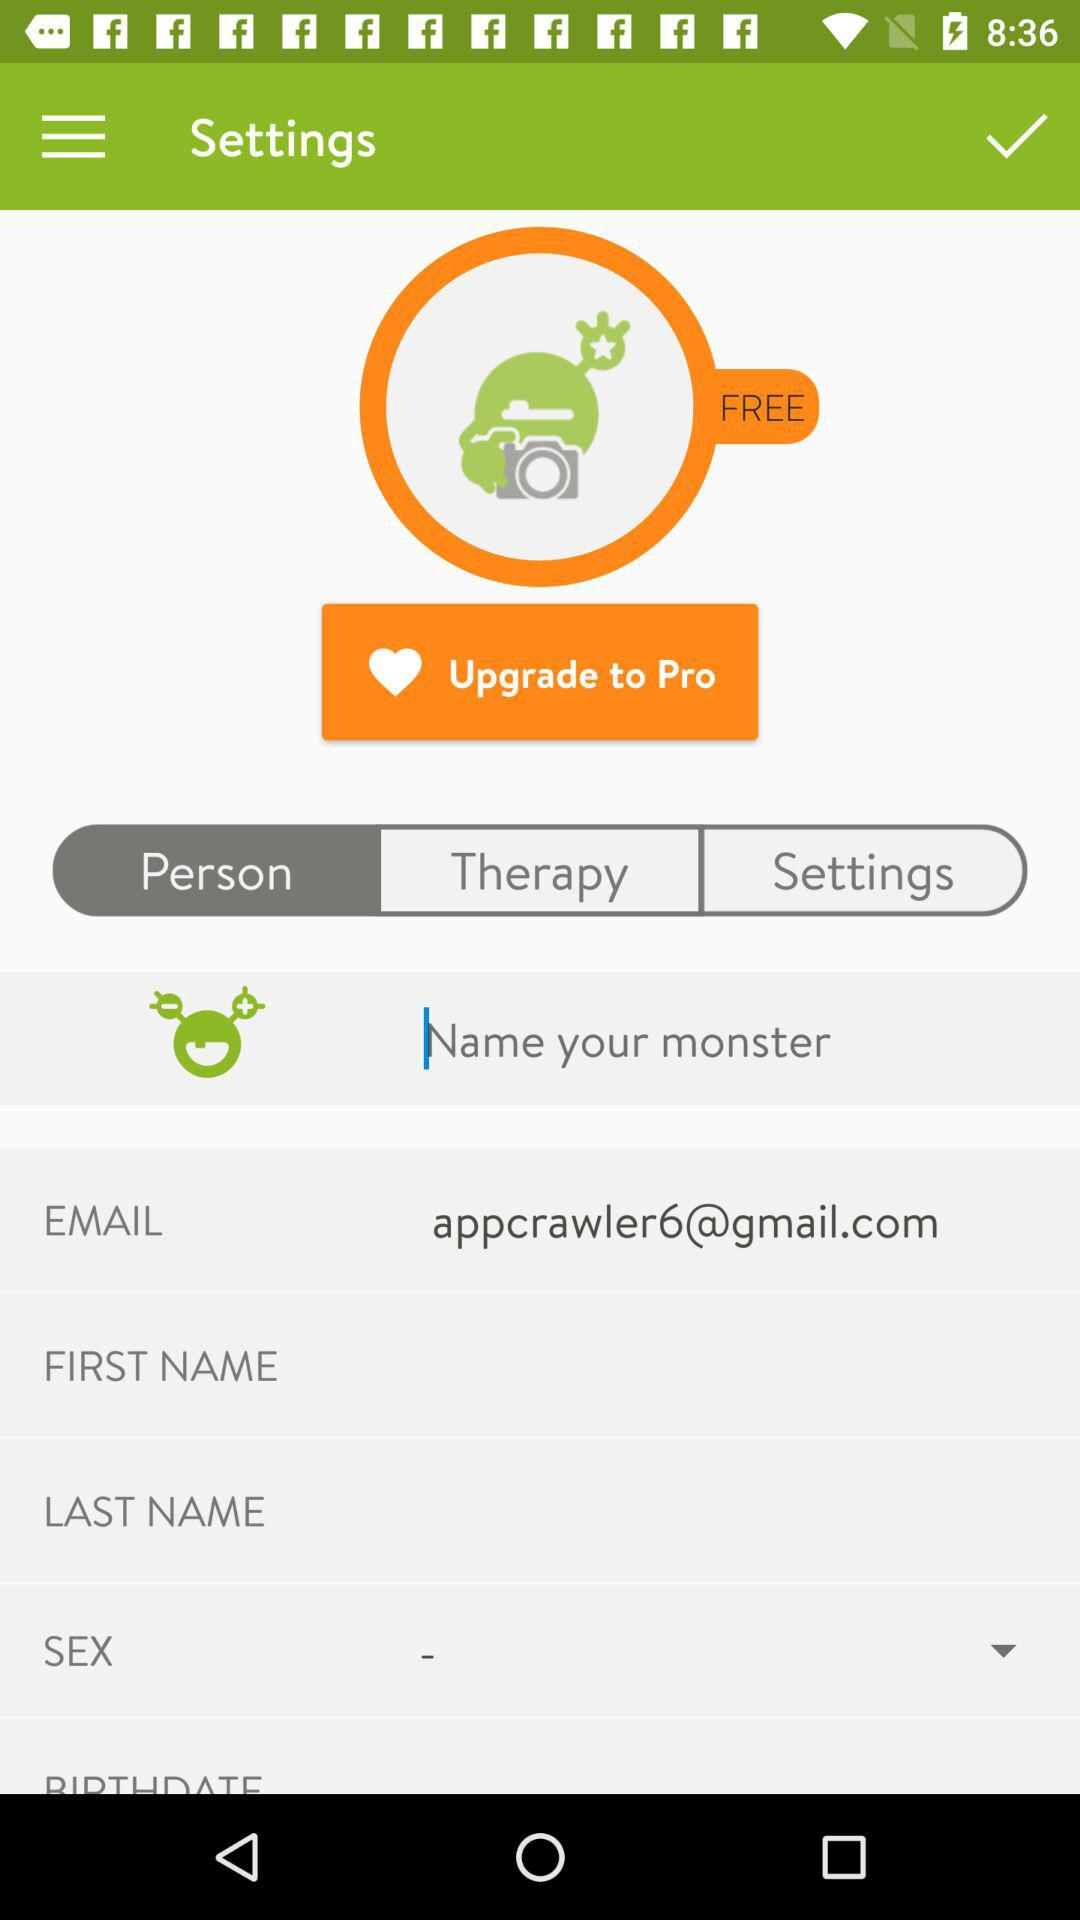When is the user's birthday?
When the provided information is insufficient, respond with <no answer>. <no answer> 